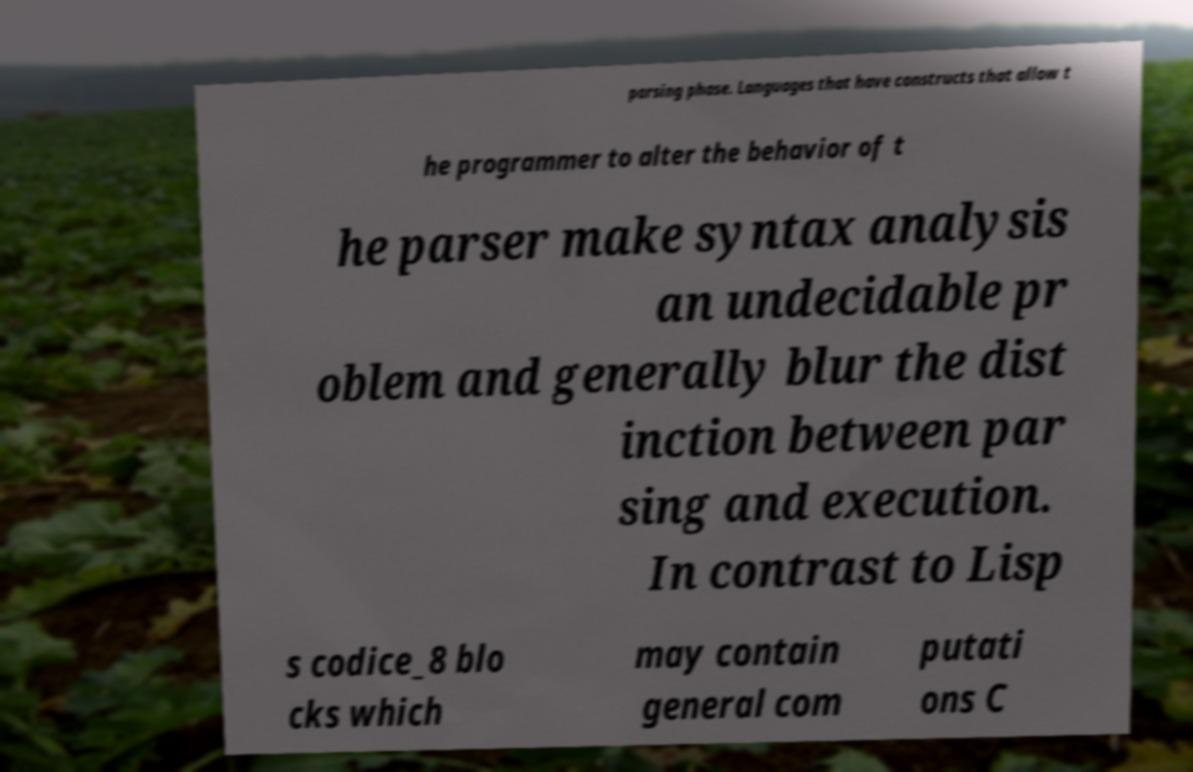Can you accurately transcribe the text from the provided image for me? parsing phase. Languages that have constructs that allow t he programmer to alter the behavior of t he parser make syntax analysis an undecidable pr oblem and generally blur the dist inction between par sing and execution. In contrast to Lisp s codice_8 blo cks which may contain general com putati ons C 